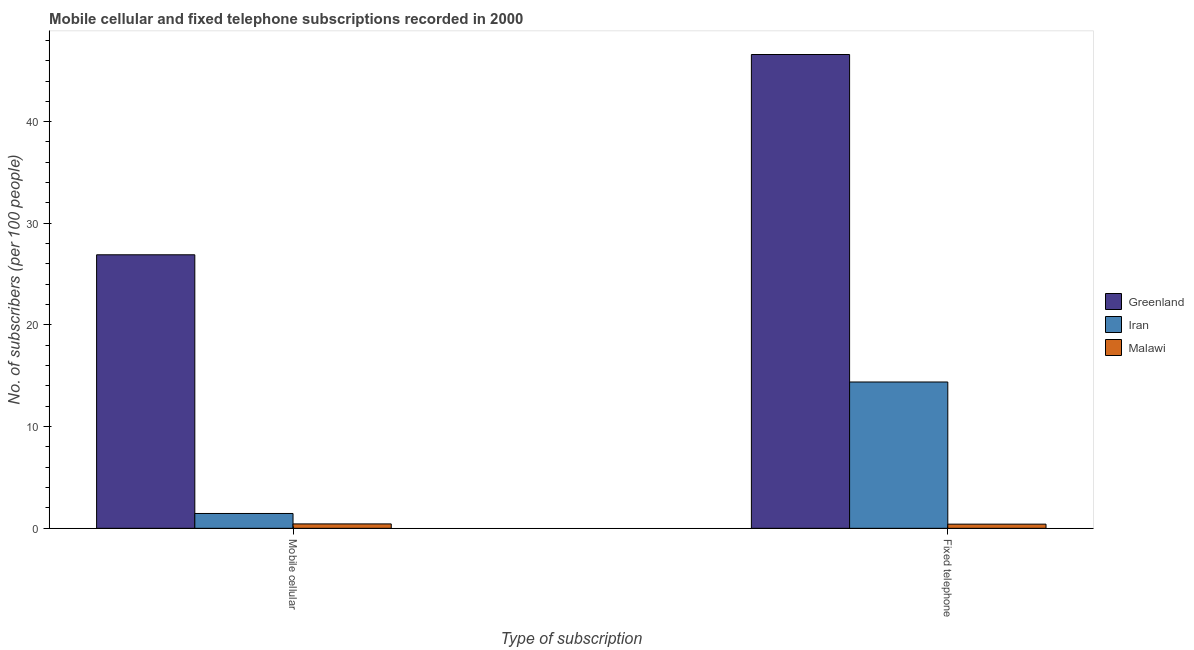How many groups of bars are there?
Give a very brief answer. 2. Are the number of bars on each tick of the X-axis equal?
Offer a very short reply. Yes. What is the label of the 1st group of bars from the left?
Provide a short and direct response. Mobile cellular. What is the number of fixed telephone subscribers in Greenland?
Your answer should be compact. 46.61. Across all countries, what is the maximum number of fixed telephone subscribers?
Make the answer very short. 46.61. Across all countries, what is the minimum number of fixed telephone subscribers?
Your answer should be very brief. 0.41. In which country was the number of mobile cellular subscribers maximum?
Offer a terse response. Greenland. In which country was the number of fixed telephone subscribers minimum?
Your response must be concise. Malawi. What is the total number of fixed telephone subscribers in the graph?
Your answer should be compact. 61.41. What is the difference between the number of mobile cellular subscribers in Greenland and that in Malawi?
Keep it short and to the point. 26.47. What is the difference between the number of mobile cellular subscribers in Iran and the number of fixed telephone subscribers in Malawi?
Keep it short and to the point. 1.05. What is the average number of mobile cellular subscribers per country?
Keep it short and to the point. 9.6. What is the difference between the number of fixed telephone subscribers and number of mobile cellular subscribers in Greenland?
Give a very brief answer. 19.7. What is the ratio of the number of mobile cellular subscribers in Iran to that in Greenland?
Offer a very short reply. 0.05. Is the number of mobile cellular subscribers in Greenland less than that in Malawi?
Your response must be concise. No. What does the 2nd bar from the left in Mobile cellular represents?
Make the answer very short. Iran. What does the 3rd bar from the right in Fixed telephone represents?
Keep it short and to the point. Greenland. What is the difference between two consecutive major ticks on the Y-axis?
Give a very brief answer. 10. Are the values on the major ticks of Y-axis written in scientific E-notation?
Offer a very short reply. No. Does the graph contain grids?
Your response must be concise. No. Where does the legend appear in the graph?
Ensure brevity in your answer.  Center right. How are the legend labels stacked?
Provide a short and direct response. Vertical. What is the title of the graph?
Offer a terse response. Mobile cellular and fixed telephone subscriptions recorded in 2000. What is the label or title of the X-axis?
Provide a succinct answer. Type of subscription. What is the label or title of the Y-axis?
Provide a succinct answer. No. of subscribers (per 100 people). What is the No. of subscribers (per 100 people) of Greenland in Mobile cellular?
Provide a succinct answer. 26.91. What is the No. of subscribers (per 100 people) of Iran in Mobile cellular?
Make the answer very short. 1.46. What is the No. of subscribers (per 100 people) of Malawi in Mobile cellular?
Offer a terse response. 0.43. What is the No. of subscribers (per 100 people) of Greenland in Fixed telephone?
Ensure brevity in your answer.  46.61. What is the No. of subscribers (per 100 people) of Iran in Fixed telephone?
Offer a very short reply. 14.39. What is the No. of subscribers (per 100 people) in Malawi in Fixed telephone?
Give a very brief answer. 0.41. Across all Type of subscription, what is the maximum No. of subscribers (per 100 people) in Greenland?
Offer a very short reply. 46.61. Across all Type of subscription, what is the maximum No. of subscribers (per 100 people) of Iran?
Keep it short and to the point. 14.39. Across all Type of subscription, what is the maximum No. of subscribers (per 100 people) in Malawi?
Your answer should be very brief. 0.43. Across all Type of subscription, what is the minimum No. of subscribers (per 100 people) in Greenland?
Offer a terse response. 26.91. Across all Type of subscription, what is the minimum No. of subscribers (per 100 people) of Iran?
Keep it short and to the point. 1.46. Across all Type of subscription, what is the minimum No. of subscribers (per 100 people) in Malawi?
Make the answer very short. 0.41. What is the total No. of subscribers (per 100 people) in Greenland in the graph?
Make the answer very short. 73.51. What is the total No. of subscribers (per 100 people) of Iran in the graph?
Give a very brief answer. 15.85. What is the total No. of subscribers (per 100 people) in Malawi in the graph?
Your response must be concise. 0.84. What is the difference between the No. of subscribers (per 100 people) of Greenland in Mobile cellular and that in Fixed telephone?
Your answer should be compact. -19.7. What is the difference between the No. of subscribers (per 100 people) of Iran in Mobile cellular and that in Fixed telephone?
Your response must be concise. -12.93. What is the difference between the No. of subscribers (per 100 people) in Malawi in Mobile cellular and that in Fixed telephone?
Give a very brief answer. 0.02. What is the difference between the No. of subscribers (per 100 people) of Greenland in Mobile cellular and the No. of subscribers (per 100 people) of Iran in Fixed telephone?
Offer a very short reply. 12.51. What is the difference between the No. of subscribers (per 100 people) of Greenland in Mobile cellular and the No. of subscribers (per 100 people) of Malawi in Fixed telephone?
Ensure brevity in your answer.  26.5. What is the difference between the No. of subscribers (per 100 people) of Iran in Mobile cellular and the No. of subscribers (per 100 people) of Malawi in Fixed telephone?
Make the answer very short. 1.05. What is the average No. of subscribers (per 100 people) in Greenland per Type of subscription?
Give a very brief answer. 36.76. What is the average No. of subscribers (per 100 people) in Iran per Type of subscription?
Offer a very short reply. 7.93. What is the average No. of subscribers (per 100 people) in Malawi per Type of subscription?
Offer a terse response. 0.42. What is the difference between the No. of subscribers (per 100 people) in Greenland and No. of subscribers (per 100 people) in Iran in Mobile cellular?
Offer a terse response. 25.45. What is the difference between the No. of subscribers (per 100 people) of Greenland and No. of subscribers (per 100 people) of Malawi in Mobile cellular?
Keep it short and to the point. 26.47. What is the difference between the No. of subscribers (per 100 people) of Iran and No. of subscribers (per 100 people) of Malawi in Mobile cellular?
Offer a terse response. 1.03. What is the difference between the No. of subscribers (per 100 people) of Greenland and No. of subscribers (per 100 people) of Iran in Fixed telephone?
Give a very brief answer. 32.21. What is the difference between the No. of subscribers (per 100 people) in Greenland and No. of subscribers (per 100 people) in Malawi in Fixed telephone?
Your answer should be very brief. 46.2. What is the difference between the No. of subscribers (per 100 people) in Iran and No. of subscribers (per 100 people) in Malawi in Fixed telephone?
Your answer should be very brief. 13.98. What is the ratio of the No. of subscribers (per 100 people) of Greenland in Mobile cellular to that in Fixed telephone?
Give a very brief answer. 0.58. What is the ratio of the No. of subscribers (per 100 people) of Iran in Mobile cellular to that in Fixed telephone?
Ensure brevity in your answer.  0.1. What is the ratio of the No. of subscribers (per 100 people) in Malawi in Mobile cellular to that in Fixed telephone?
Offer a terse response. 1.05. What is the difference between the highest and the second highest No. of subscribers (per 100 people) of Greenland?
Give a very brief answer. 19.7. What is the difference between the highest and the second highest No. of subscribers (per 100 people) in Iran?
Keep it short and to the point. 12.93. What is the difference between the highest and the second highest No. of subscribers (per 100 people) of Malawi?
Give a very brief answer. 0.02. What is the difference between the highest and the lowest No. of subscribers (per 100 people) in Greenland?
Offer a terse response. 19.7. What is the difference between the highest and the lowest No. of subscribers (per 100 people) of Iran?
Provide a short and direct response. 12.93. What is the difference between the highest and the lowest No. of subscribers (per 100 people) of Malawi?
Your answer should be very brief. 0.02. 